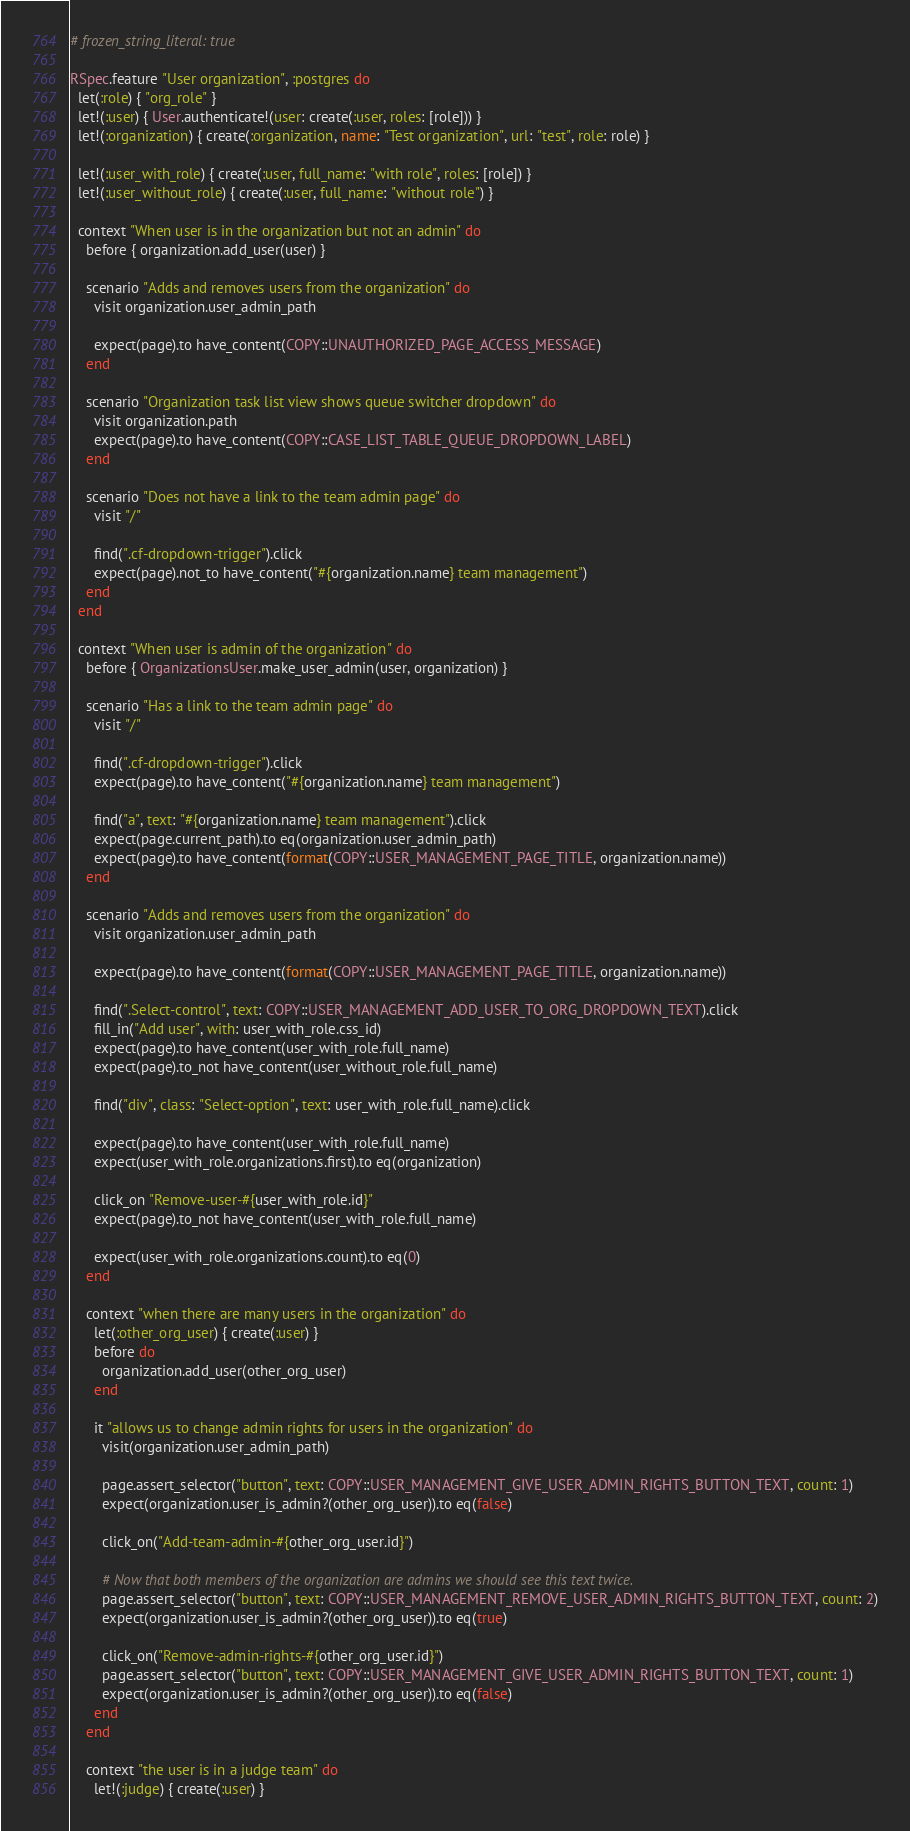<code> <loc_0><loc_0><loc_500><loc_500><_Ruby_># frozen_string_literal: true

RSpec.feature "User organization", :postgres do
  let(:role) { "org_role" }
  let!(:user) { User.authenticate!(user: create(:user, roles: [role])) }
  let!(:organization) { create(:organization, name: "Test organization", url: "test", role: role) }

  let!(:user_with_role) { create(:user, full_name: "with role", roles: [role]) }
  let!(:user_without_role) { create(:user, full_name: "without role") }

  context "When user is in the organization but not an admin" do
    before { organization.add_user(user) }

    scenario "Adds and removes users from the organization" do
      visit organization.user_admin_path

      expect(page).to have_content(COPY::UNAUTHORIZED_PAGE_ACCESS_MESSAGE)
    end

    scenario "Organization task list view shows queue switcher dropdown" do
      visit organization.path
      expect(page).to have_content(COPY::CASE_LIST_TABLE_QUEUE_DROPDOWN_LABEL)
    end

    scenario "Does not have a link to the team admin page" do
      visit "/"

      find(".cf-dropdown-trigger").click
      expect(page).not_to have_content("#{organization.name} team management")
    end
  end

  context "When user is admin of the organization" do
    before { OrganizationsUser.make_user_admin(user, organization) }

    scenario "Has a link to the team admin page" do
      visit "/"

      find(".cf-dropdown-trigger").click
      expect(page).to have_content("#{organization.name} team management")

      find("a", text: "#{organization.name} team management").click
      expect(page.current_path).to eq(organization.user_admin_path)
      expect(page).to have_content(format(COPY::USER_MANAGEMENT_PAGE_TITLE, organization.name))
    end

    scenario "Adds and removes users from the organization" do
      visit organization.user_admin_path

      expect(page).to have_content(format(COPY::USER_MANAGEMENT_PAGE_TITLE, organization.name))

      find(".Select-control", text: COPY::USER_MANAGEMENT_ADD_USER_TO_ORG_DROPDOWN_TEXT).click
      fill_in("Add user", with: user_with_role.css_id)
      expect(page).to have_content(user_with_role.full_name)
      expect(page).to_not have_content(user_without_role.full_name)

      find("div", class: "Select-option", text: user_with_role.full_name).click

      expect(page).to have_content(user_with_role.full_name)
      expect(user_with_role.organizations.first).to eq(organization)

      click_on "Remove-user-#{user_with_role.id}"
      expect(page).to_not have_content(user_with_role.full_name)

      expect(user_with_role.organizations.count).to eq(0)
    end

    context "when there are many users in the organization" do
      let(:other_org_user) { create(:user) }
      before do
        organization.add_user(other_org_user)
      end

      it "allows us to change admin rights for users in the organization" do
        visit(organization.user_admin_path)

        page.assert_selector("button", text: COPY::USER_MANAGEMENT_GIVE_USER_ADMIN_RIGHTS_BUTTON_TEXT, count: 1)
        expect(organization.user_is_admin?(other_org_user)).to eq(false)

        click_on("Add-team-admin-#{other_org_user.id}")

        # Now that both members of the organization are admins we should see this text twice.
        page.assert_selector("button", text: COPY::USER_MANAGEMENT_REMOVE_USER_ADMIN_RIGHTS_BUTTON_TEXT, count: 2)
        expect(organization.user_is_admin?(other_org_user)).to eq(true)

        click_on("Remove-admin-rights-#{other_org_user.id}")
        page.assert_selector("button", text: COPY::USER_MANAGEMENT_GIVE_USER_ADMIN_RIGHTS_BUTTON_TEXT, count: 1)
        expect(organization.user_is_admin?(other_org_user)).to eq(false)
      end
    end

    context "the user is in a judge team" do
      let!(:judge) { create(:user) }</code> 